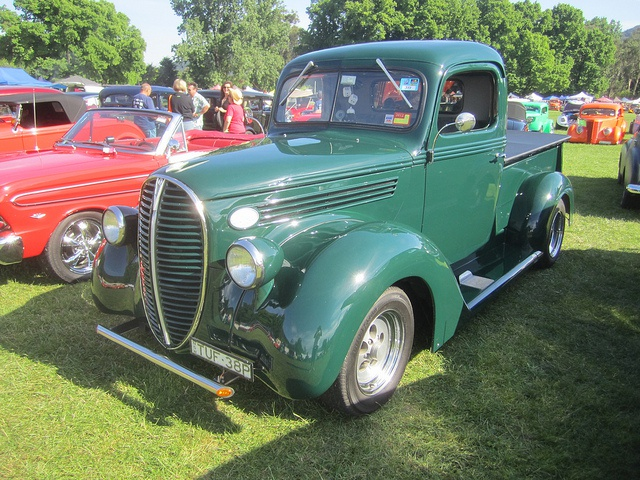Describe the objects in this image and their specific colors. I can see truck in lavender, gray, teal, and black tones, car in lavender, salmon, lightpink, darkgray, and white tones, car in lavender, salmon, gray, and black tones, car in lavender, orange, red, salmon, and brown tones, and car in lavender, gray, black, and olive tones in this image. 